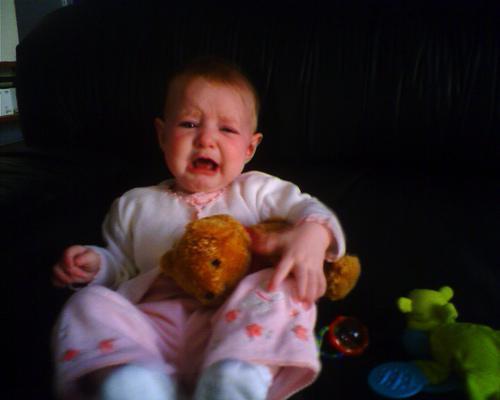Is the statement "The couch is under the person." accurate regarding the image?
Answer yes or no. Yes. 